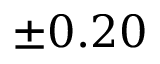<formula> <loc_0><loc_0><loc_500><loc_500>\pm 0 . 2 0</formula> 